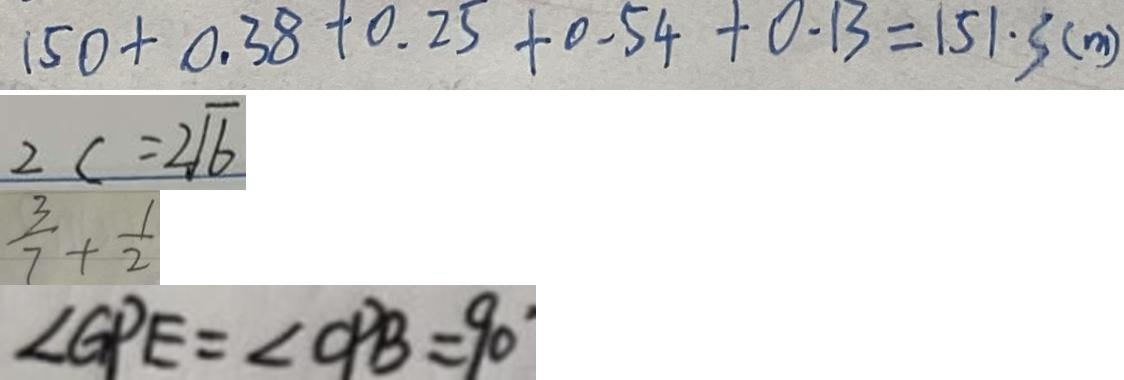Convert formula to latex. <formula><loc_0><loc_0><loc_500><loc_500>1 5 0 + 0 . 3 8 + 0 . 2 5 + 0 . 5 4 + 0 . 1 3 = 1 5 1 \cdot 3 ( m ) 
 2 c = 2 \sqrt { 6 } 
 \frac { 3 } { 7 } + \frac { 1 } { 2 } 
 \angle G P E = \angle O P B = 9 0</formula> 